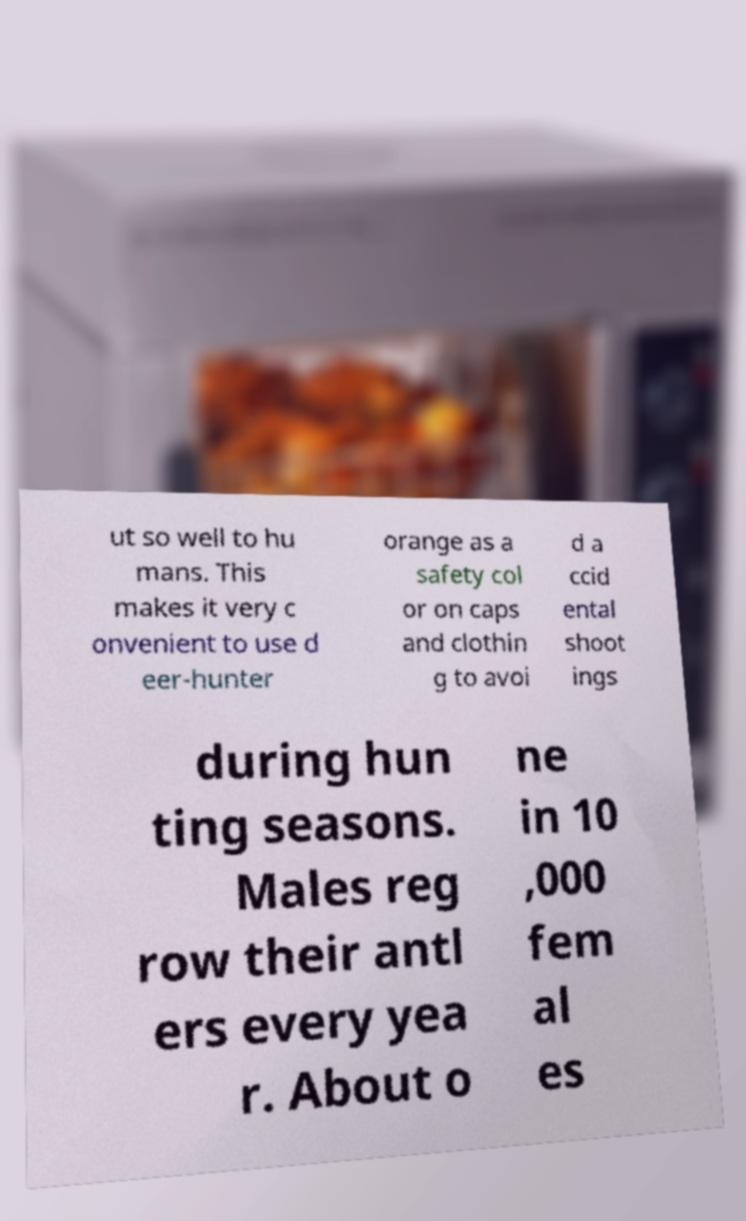Please identify and transcribe the text found in this image. ut so well to hu mans. This makes it very c onvenient to use d eer-hunter orange as a safety col or on caps and clothin g to avoi d a ccid ental shoot ings during hun ting seasons. Males reg row their antl ers every yea r. About o ne in 10 ,000 fem al es 